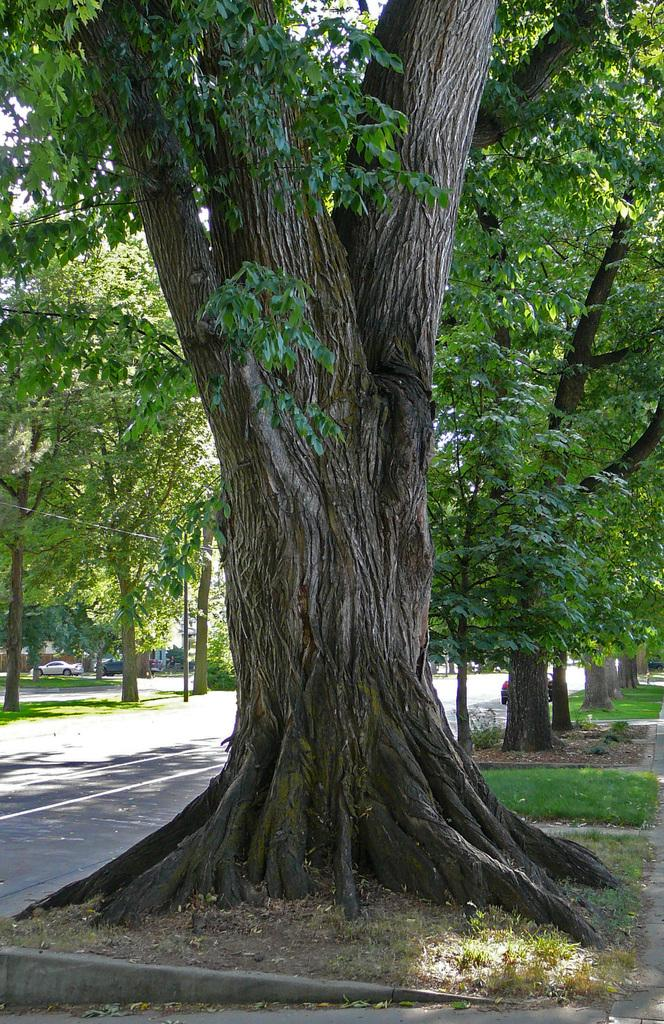What is located on the left side of the image in the foreground? There is a tree trunk in the foreground of the image on the left side. What can be seen in the foreground of the image besides the tree trunk? There is a road in the foreground of the image. What is visible in the background of the image? There are trees and grass in the background of the image. How does the tree trunk aid in the digestion of the grass in the image? The tree trunk does not aid in the digestion of the grass in the image, as it is an inanimate object and not involved in any biological processes. 